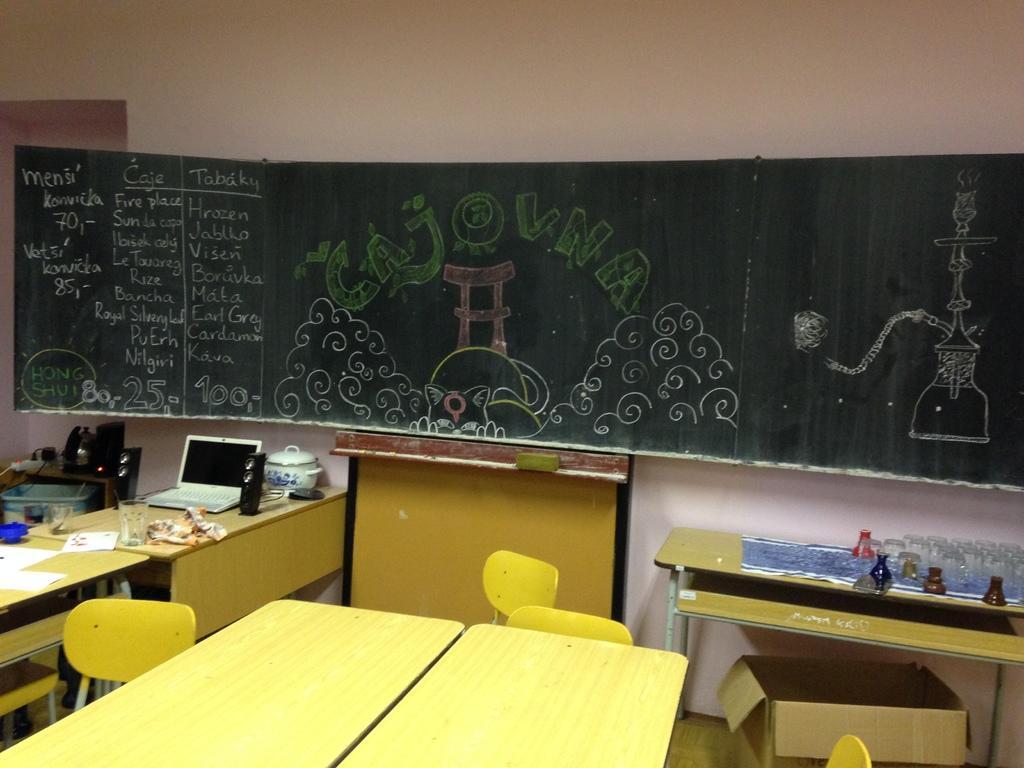Can you describe this image briefly? In this picture there are two yellow tables and four yellow chairs. There is a box. There is a laptop , bowl, glass, cloth, diapers , glasses, vase on the table. There are few objects on the table at the background. There is a blue tub. There is a blackboard on the wall. 